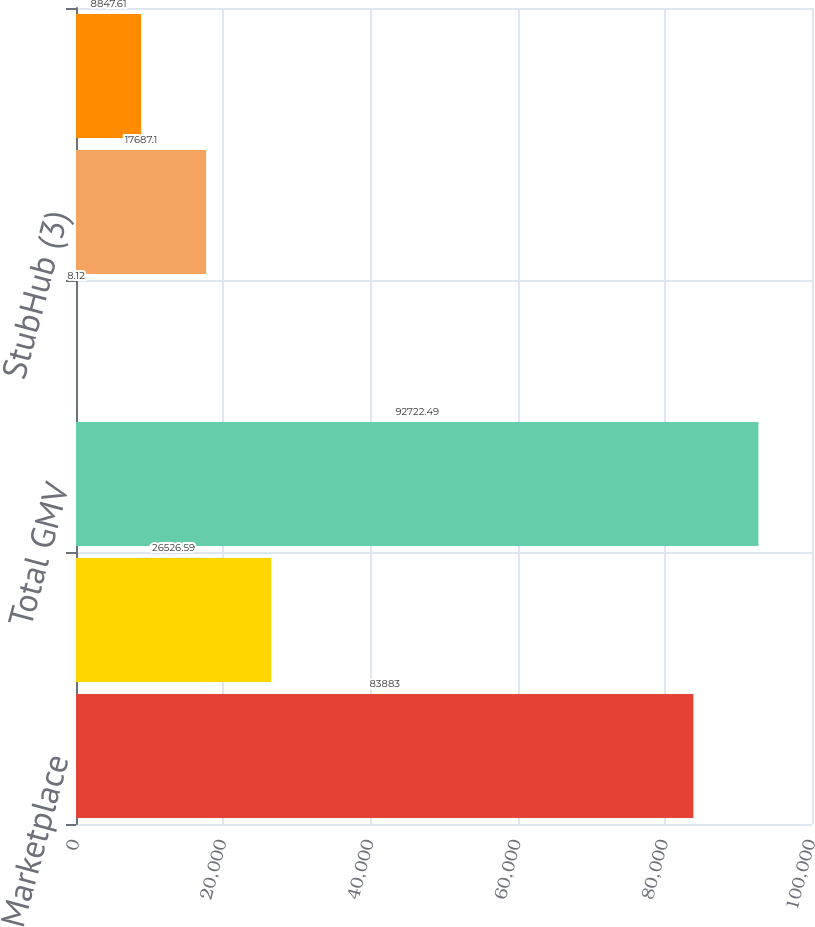<chart> <loc_0><loc_0><loc_500><loc_500><bar_chart><fcel>Marketplace<fcel>StubHub<fcel>Total GMV<fcel>Marketplace (2)<fcel>StubHub (3)<fcel>Total transaction take rate<nl><fcel>83883<fcel>26526.6<fcel>92722.5<fcel>8.12<fcel>17687.1<fcel>8847.61<nl></chart> 